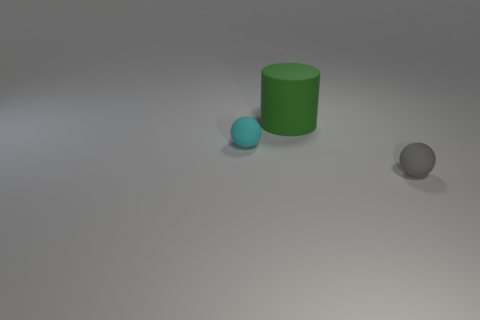What number of objects are both behind the small cyan rubber ball and in front of the green cylinder?
Offer a very short reply. 0. Are there any tiny matte balls behind the tiny gray thing?
Keep it short and to the point. Yes. Are there the same number of large objects on the left side of the green rubber thing and cyan rubber balls?
Give a very brief answer. No. There is a sphere in front of the matte object left of the large green cylinder; is there a small matte thing that is in front of it?
Your answer should be very brief. No. What number of other objects are the same shape as the large green object?
Provide a short and direct response. 0. Does the tiny gray rubber thing have the same shape as the tiny cyan thing?
Your response must be concise. Yes. How many things are matte things to the right of the small cyan object or matte things in front of the cyan sphere?
Provide a short and direct response. 2. What number of objects are either cyan objects or big green things?
Provide a succinct answer. 2. There is a ball that is to the right of the large cylinder; what number of tiny cyan balls are in front of it?
Provide a succinct answer. 0. How many other things are the same size as the green object?
Make the answer very short. 0. 